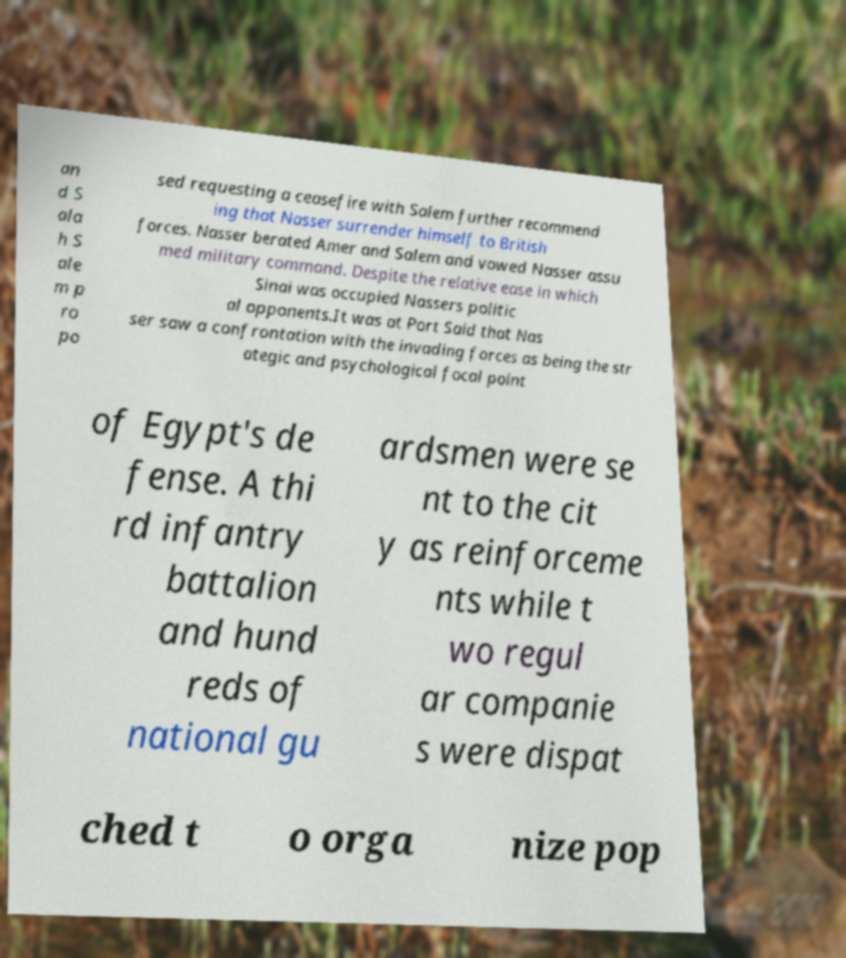Can you accurately transcribe the text from the provided image for me? an d S ala h S ale m p ro po sed requesting a ceasefire with Salem further recommend ing that Nasser surrender himself to British forces. Nasser berated Amer and Salem and vowed Nasser assu med military command. Despite the relative ease in which Sinai was occupied Nassers politic al opponents.It was at Port Said that Nas ser saw a confrontation with the invading forces as being the str ategic and psychological focal point of Egypt's de fense. A thi rd infantry battalion and hund reds of national gu ardsmen were se nt to the cit y as reinforceme nts while t wo regul ar companie s were dispat ched t o orga nize pop 